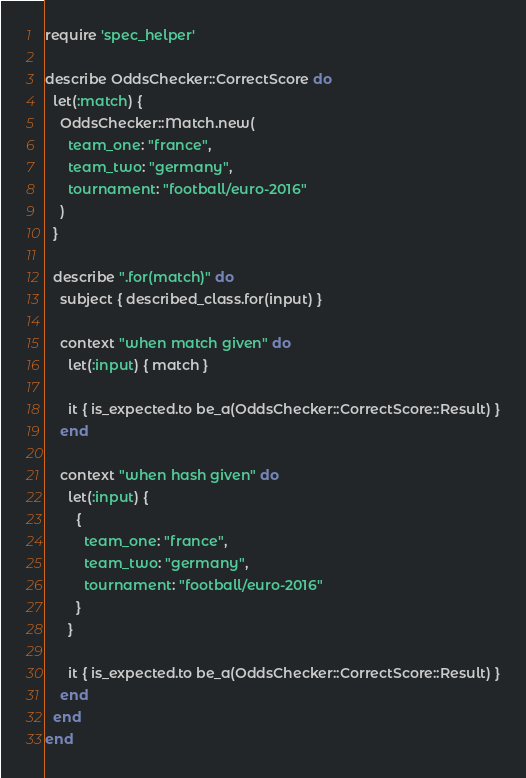<code> <loc_0><loc_0><loc_500><loc_500><_Ruby_>require 'spec_helper'

describe OddsChecker::CorrectScore do
  let(:match) {
    OddsChecker::Match.new(
      team_one: "france",
      team_two: "germany",
      tournament: "football/euro-2016"
    )
  }

  describe ".for(match)" do
    subject { described_class.for(input) }

    context "when match given" do
      let(:input) { match }

      it { is_expected.to be_a(OddsChecker::CorrectScore::Result) }
    end

    context "when hash given" do
      let(:input) {
        {
          team_one: "france",
          team_two: "germany",
          tournament: "football/euro-2016"
        }
      }

      it { is_expected.to be_a(OddsChecker::CorrectScore::Result) }
    end
  end
end
</code> 